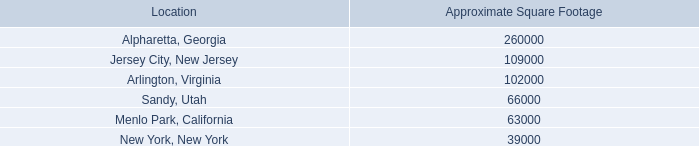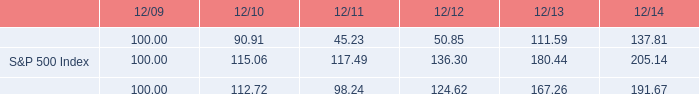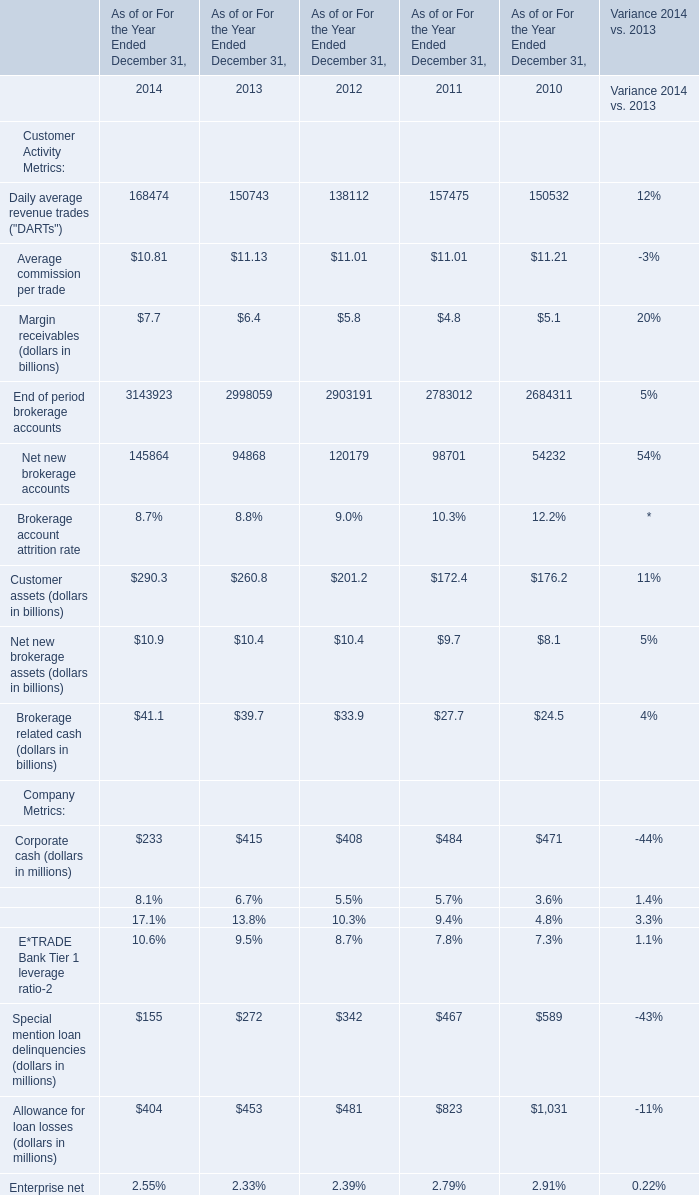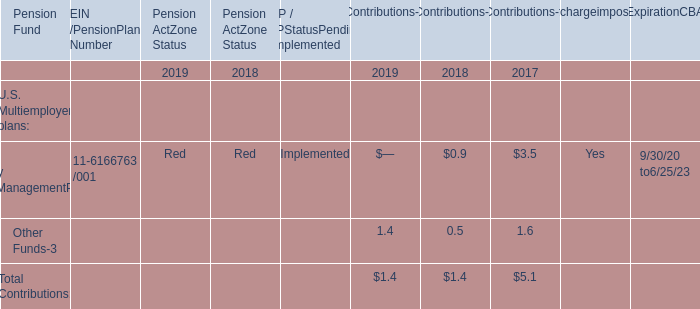What was the average of Daily average revenue trades ("DARTs") in 2014, 2013, and 2012? 
Computations: (((168474 + 150743) + 138112) / 3)
Answer: 152443.0. 